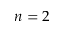Convert formula to latex. <formula><loc_0><loc_0><loc_500><loc_500>n = 2</formula> 